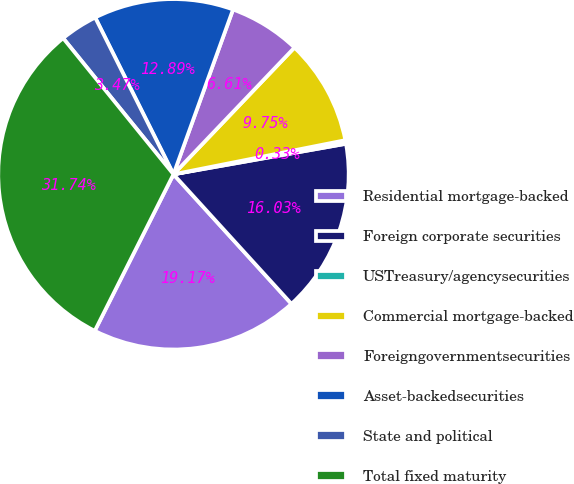Convert chart to OTSL. <chart><loc_0><loc_0><loc_500><loc_500><pie_chart><fcel>Residential mortgage-backed<fcel>Foreign corporate securities<fcel>USTreasury/agencysecurities<fcel>Commercial mortgage-backed<fcel>Foreigngovernmentsecurities<fcel>Asset-backedsecurities<fcel>State and political<fcel>Total fixed maturity<nl><fcel>19.17%<fcel>16.03%<fcel>0.33%<fcel>9.75%<fcel>6.61%<fcel>12.89%<fcel>3.47%<fcel>31.74%<nl></chart> 